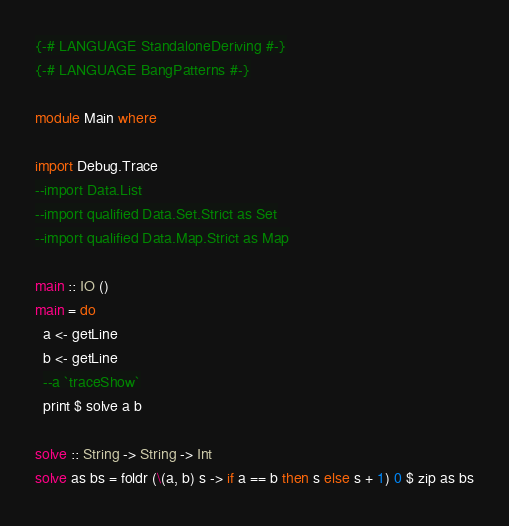<code> <loc_0><loc_0><loc_500><loc_500><_Haskell_>
{-# LANGUAGE StandaloneDeriving #-}
{-# LANGUAGE BangPatterns #-}

module Main where

import Debug.Trace
--import Data.List
--import qualified Data.Set.Strict as Set
--import qualified Data.Map.Strict as Map

main :: IO ()
main = do
  a <- getLine
  b <- getLine
  --a `traceShow`
  print $ solve a b

solve :: String -> String -> Int
solve as bs = foldr (\(a, b) s -> if a == b then s else s + 1) 0 $ zip as bs
</code> 